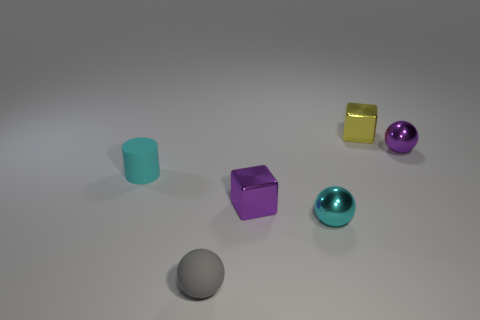What is the color of the other metallic sphere that is the same size as the purple sphere? cyan 